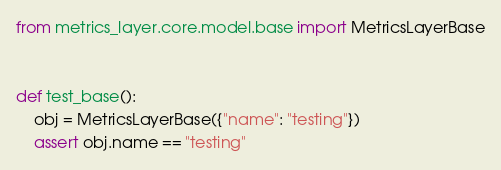Convert code to text. <code><loc_0><loc_0><loc_500><loc_500><_Python_>from metrics_layer.core.model.base import MetricsLayerBase


def test_base():
    obj = MetricsLayerBase({"name": "testing"})
    assert obj.name == "testing"
</code> 